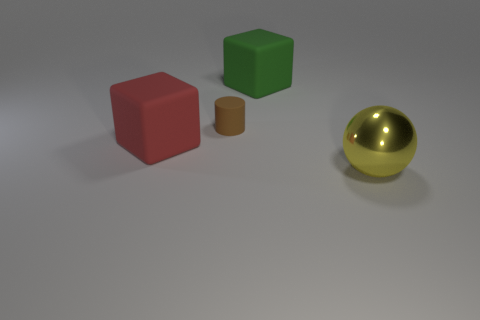Add 4 tiny purple matte spheres. How many objects exist? 8 Subtract all green blocks. How many blocks are left? 1 Subtract all cylinders. How many objects are left? 3 Subtract all blue cylinders. How many cyan spheres are left? 0 Subtract all metallic balls. Subtract all small green cylinders. How many objects are left? 3 Add 4 large matte things. How many large matte things are left? 6 Add 1 large rubber objects. How many large rubber objects exist? 3 Subtract 0 blue cylinders. How many objects are left? 4 Subtract 1 cylinders. How many cylinders are left? 0 Subtract all purple blocks. Subtract all purple balls. How many blocks are left? 2 